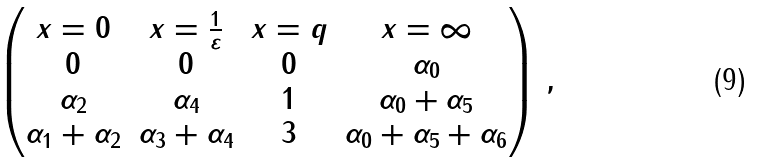<formula> <loc_0><loc_0><loc_500><loc_500>\begin{pmatrix} x = 0 & x = \frac { 1 } { \varepsilon } & x = q & x = \infty \\ 0 & 0 & 0 & \alpha _ { 0 } \\ \alpha _ { 2 } & \alpha _ { 4 } & 1 & \alpha _ { 0 } + \alpha _ { 5 } \\ \alpha _ { 1 } + \alpha _ { 2 } & \alpha _ { 3 } + \alpha _ { 4 } & 3 & \alpha _ { 0 } + \alpha _ { 5 } + \alpha _ { 6 } \end{pmatrix} \, ,</formula> 